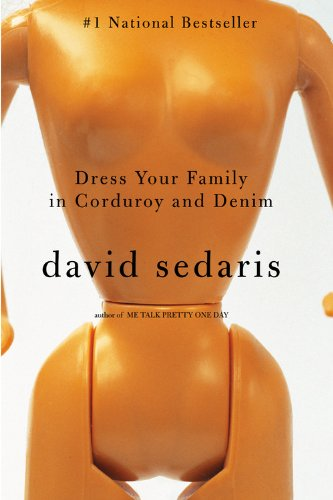Is this book related to Reference? No, this book is not related to the Reference genre. It is primarily an autobiographical collection of essays infused with humor. 